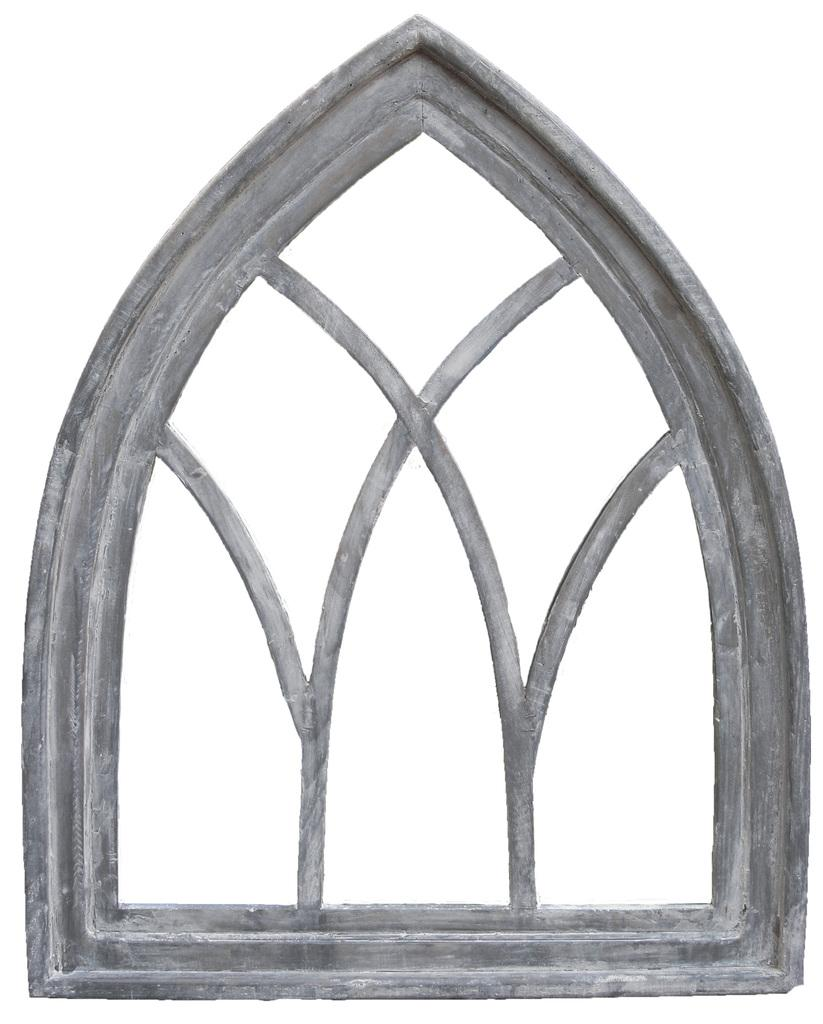What is the main subject of the image? The main subject of the image is a sketch of an object. What type of oatmeal is being cooked in the image? There is no oatmeal present in the image; it only contains a sketch of an object. Is the person in the image stuck in quicksand? There is no person or quicksand present in the image; it only contains a sketch of an object. 